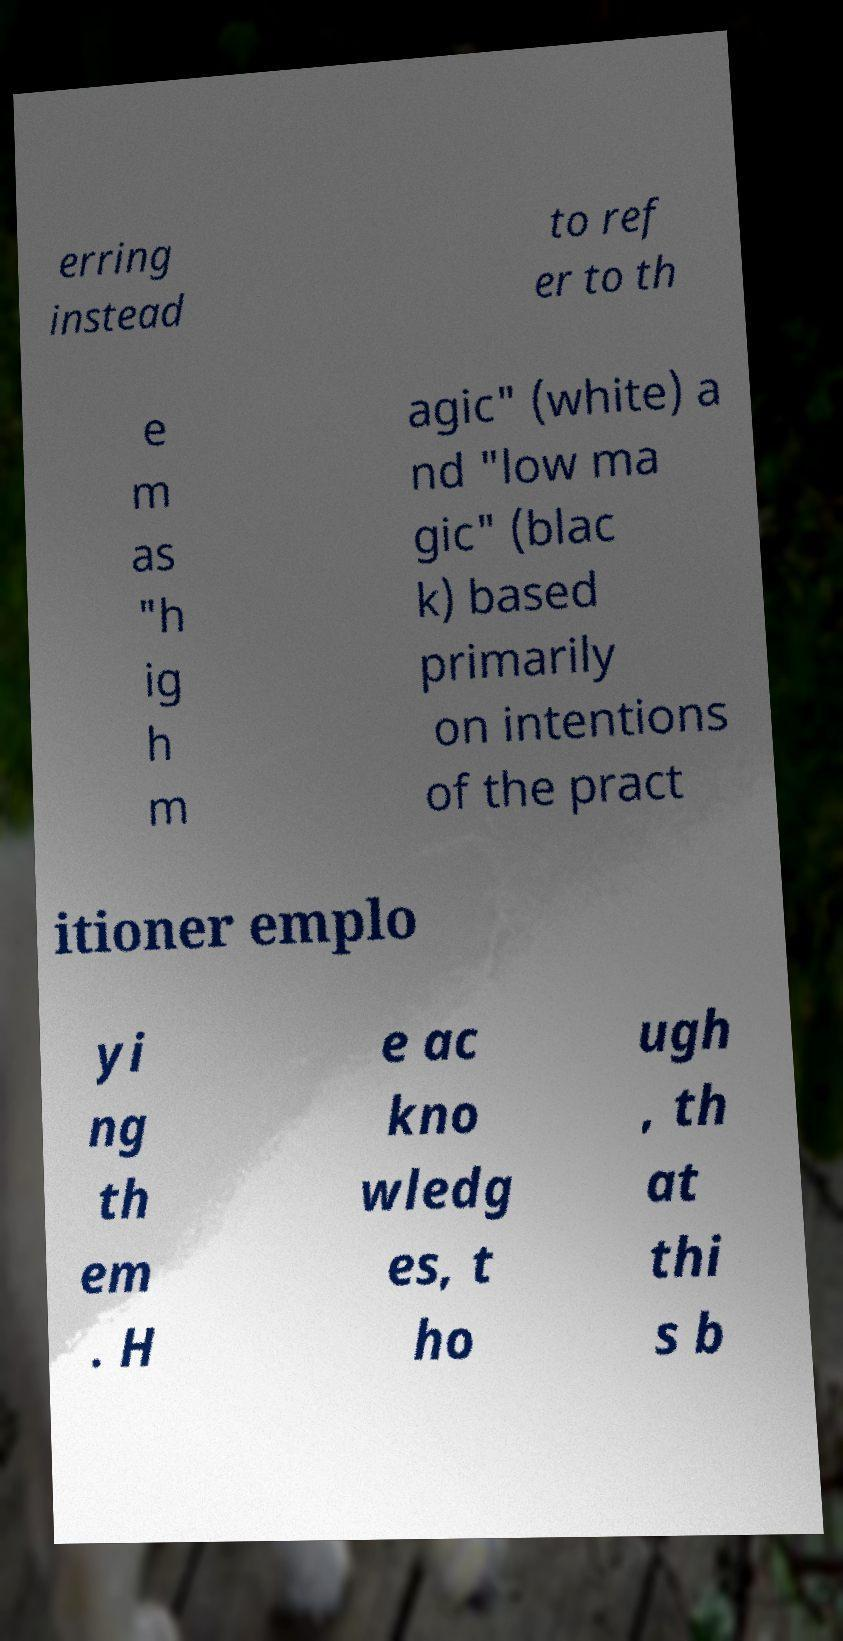I need the written content from this picture converted into text. Can you do that? erring instead to ref er to th e m as "h ig h m agic" (white) a nd "low ma gic" (blac k) based primarily on intentions of the pract itioner emplo yi ng th em . H e ac kno wledg es, t ho ugh , th at thi s b 